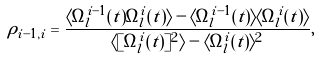Convert formula to latex. <formula><loc_0><loc_0><loc_500><loc_500>\rho _ { i - 1 , i } = \frac { \langle \Omega _ { l } ^ { i - 1 } ( t ) \Omega _ { l } ^ { i } ( t ) \rangle - \langle \Omega _ { l } ^ { i - 1 } ( t ) \rangle \langle \Omega _ { l } ^ { i } ( t ) \rangle } { \langle [ \Omega _ { l } ^ { i } ( t ) ] ^ { 2 } \rangle - \langle \Omega _ { l } ^ { i } ( t ) \rangle ^ { 2 } } ,</formula> 